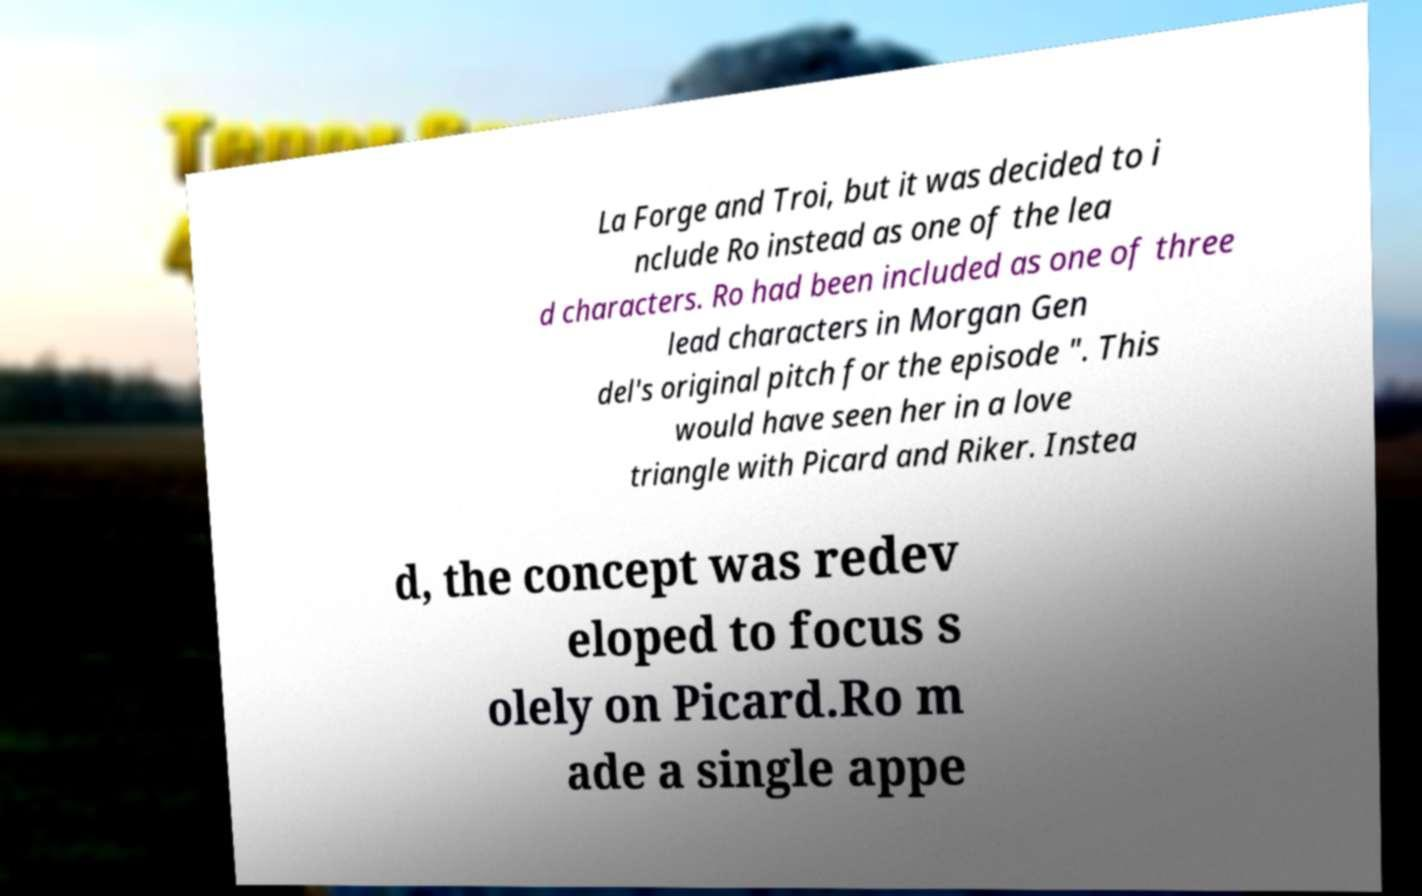Could you assist in decoding the text presented in this image and type it out clearly? La Forge and Troi, but it was decided to i nclude Ro instead as one of the lea d characters. Ro had been included as one of three lead characters in Morgan Gen del's original pitch for the episode ". This would have seen her in a love triangle with Picard and Riker. Instea d, the concept was redev eloped to focus s olely on Picard.Ro m ade a single appe 